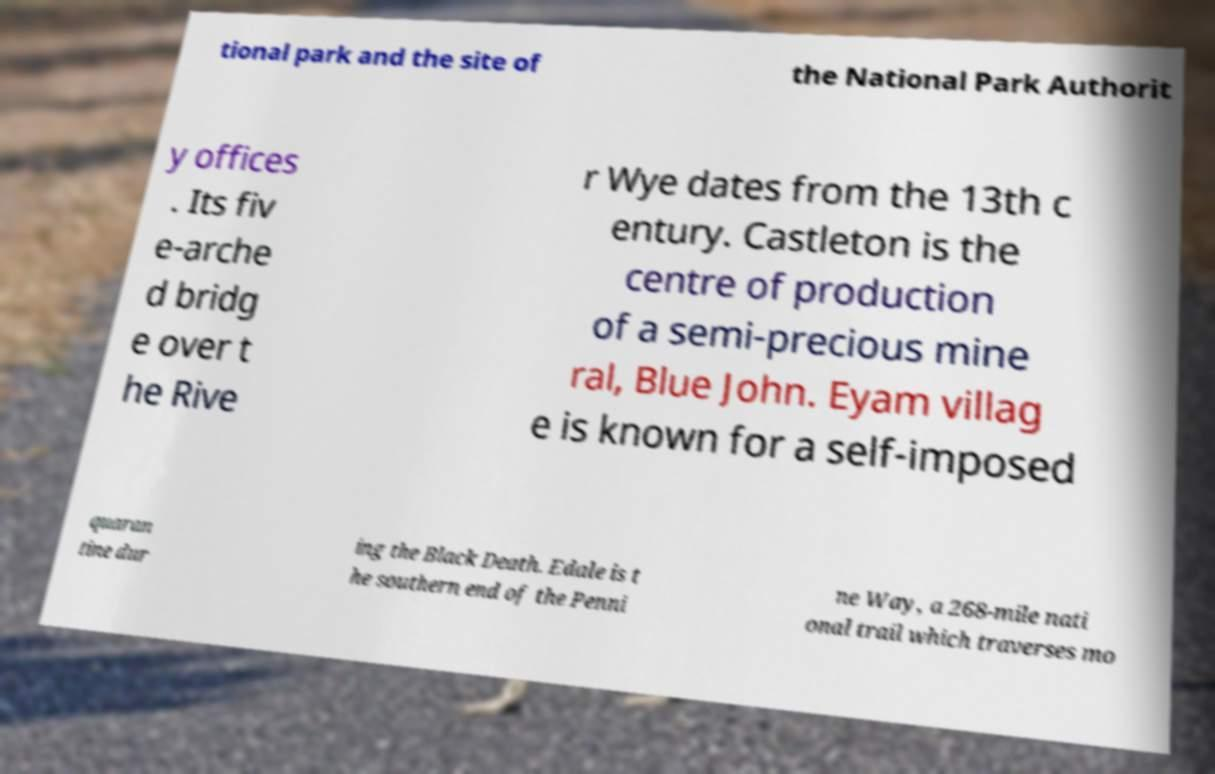Please read and relay the text visible in this image. What does it say? tional park and the site of the National Park Authorit y offices . Its fiv e-arche d bridg e over t he Rive r Wye dates from the 13th c entury. Castleton is the centre of production of a semi-precious mine ral, Blue John. Eyam villag e is known for a self-imposed quaran tine dur ing the Black Death. Edale is t he southern end of the Penni ne Way, a 268-mile nati onal trail which traverses mo 